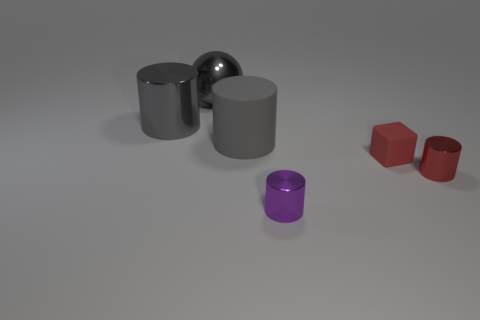Please describe the material and shape of the object furthest to my left. The object furthest to the left is a matte red hexagon, which appears to be a solid geometric shape made of a plastic or powder-coated metal.  What’s the apparent texture of the two gray objects in the center? The two gray objects in the center exhibit a smooth texture. The leftmost one, in particular, has a highly polished finish that reflects the light, suggesting it is a metal. The right one has a more diffused reflection, which could indicate it is made of ceramic or another non-metallic material. 